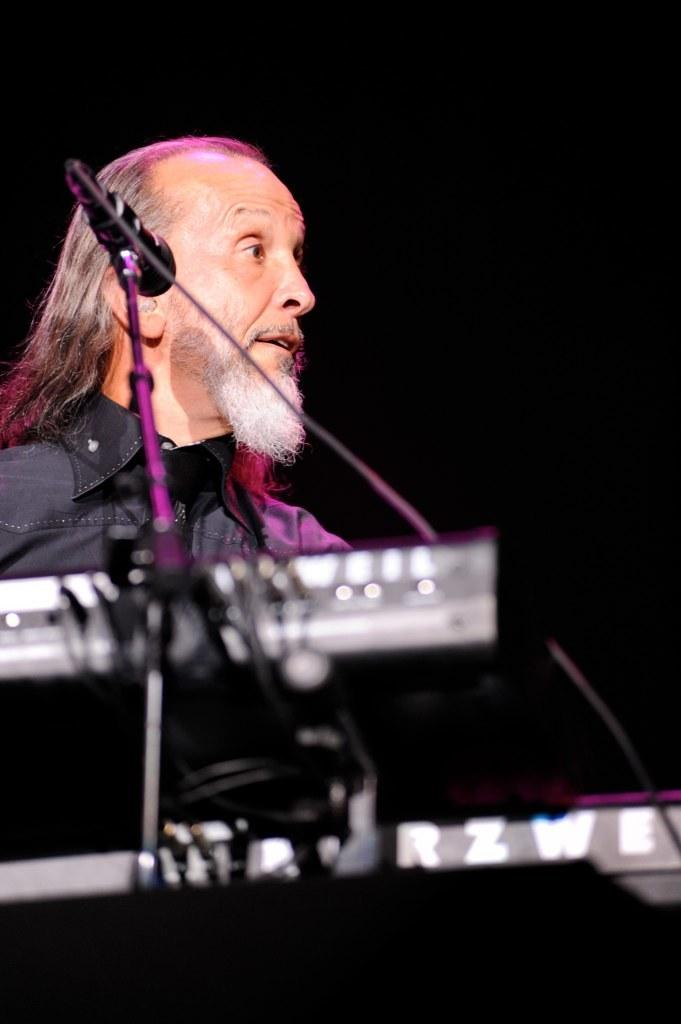What is the appearance of the man in the image? The man has a white beard and long hair. What is the man holding in the image? There is a musical instrument in the image. What device is present for amplifying the man's voice? There is a microphone in the image. How many chickens are visible in the image? There are no chickens present in the image. What level of difficulty is the man facing in the image? The image does not indicate any level of difficulty or challenge for the man. 